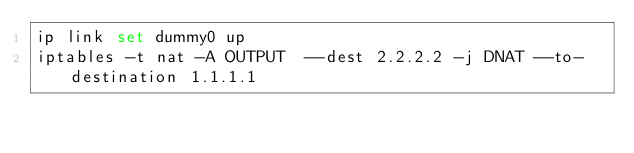<code> <loc_0><loc_0><loc_500><loc_500><_Bash_>ip link set dummy0 up
iptables -t nat -A OUTPUT  --dest 2.2.2.2 -j DNAT --to-destination 1.1.1.1
</code> 